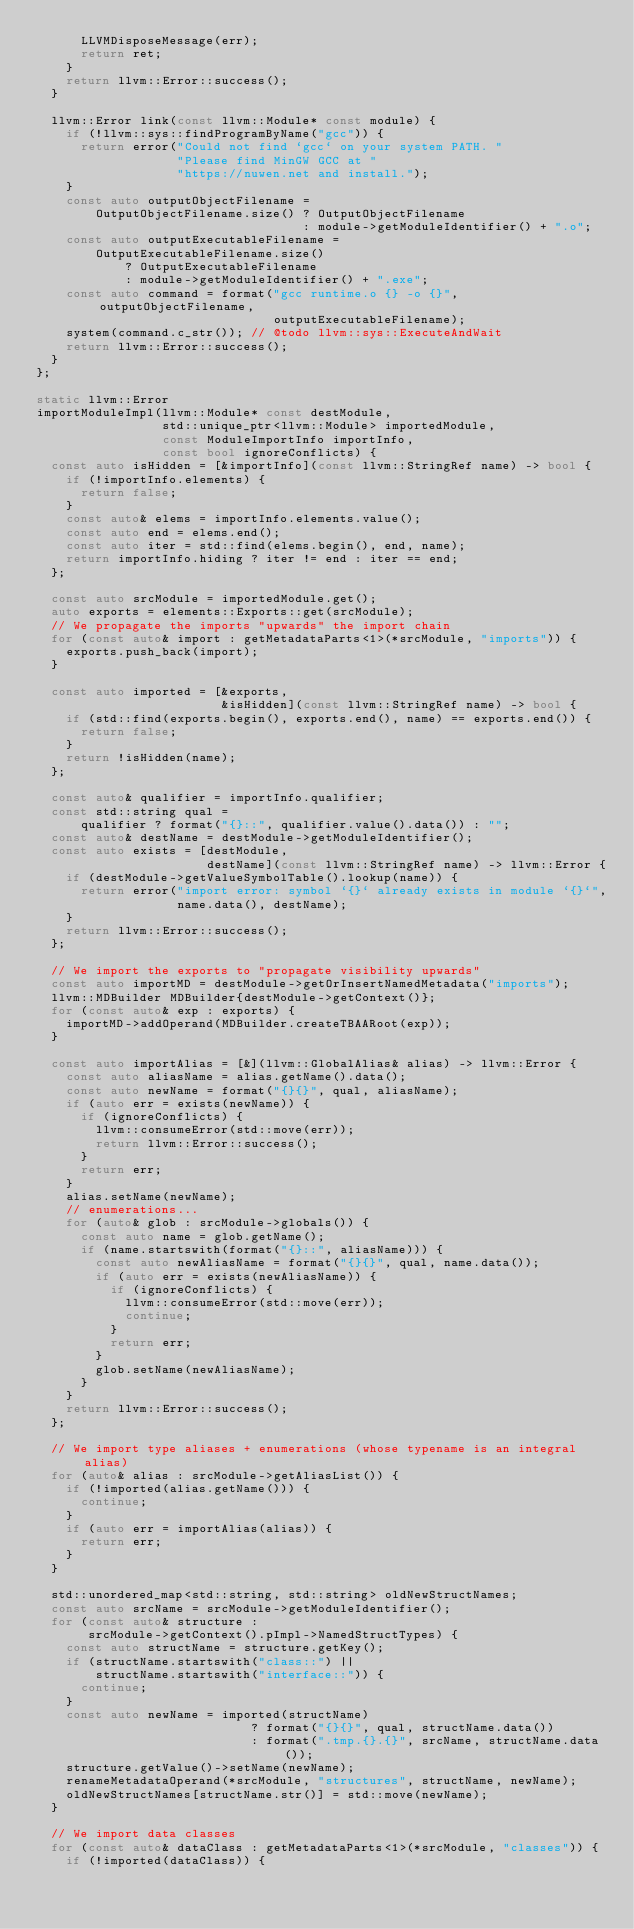<code> <loc_0><loc_0><loc_500><loc_500><_C++_>      LLVMDisposeMessage(err);
      return ret;
    }
    return llvm::Error::success();
  }

  llvm::Error link(const llvm::Module* const module) {
    if (!llvm::sys::findProgramByName("gcc")) {
      return error("Could not find `gcc` on your system PATH. "
                   "Please find MinGW GCC at "
                   "https://nuwen.net and install.");
    }
    const auto outputObjectFilename =
        OutputObjectFilename.size() ? OutputObjectFilename
                                    : module->getModuleIdentifier() + ".o";
    const auto outputExecutableFilename =
        OutputExecutableFilename.size()
            ? OutputExecutableFilename
            : module->getModuleIdentifier() + ".exe";
    const auto command = format("gcc runtime.o {} -o {}", outputObjectFilename,
                                outputExecutableFilename);
    system(command.c_str()); // @todo llvm::sys::ExecuteAndWait
    return llvm::Error::success();
  }
};

static llvm::Error
importModuleImpl(llvm::Module* const destModule,
                 std::unique_ptr<llvm::Module> importedModule,
                 const ModuleImportInfo importInfo,
                 const bool ignoreConflicts) {
  const auto isHidden = [&importInfo](const llvm::StringRef name) -> bool {
    if (!importInfo.elements) {
      return false;
    }
    const auto& elems = importInfo.elements.value();
    const auto end = elems.end();
    const auto iter = std::find(elems.begin(), end, name);
    return importInfo.hiding ? iter != end : iter == end;
  };

  const auto srcModule = importedModule.get();
  auto exports = elements::Exports::get(srcModule);
  // We propagate the imports "upwards" the import chain
  for (const auto& import : getMetadataParts<1>(*srcModule, "imports")) {
    exports.push_back(import);
  }

  const auto imported = [&exports,
                         &isHidden](const llvm::StringRef name) -> bool {
    if (std::find(exports.begin(), exports.end(), name) == exports.end()) {
      return false;
    }
    return !isHidden(name);
  };

  const auto& qualifier = importInfo.qualifier;
  const std::string qual =
      qualifier ? format("{}::", qualifier.value().data()) : "";
  const auto& destName = destModule->getModuleIdentifier();
  const auto exists = [destModule,
                       destName](const llvm::StringRef name) -> llvm::Error {
    if (destModule->getValueSymbolTable().lookup(name)) {
      return error("import error: symbol `{}` already exists in module `{}`",
                   name.data(), destName);
    }
    return llvm::Error::success();
  };

  // We import the exports to "propagate visibility upwards"
  const auto importMD = destModule->getOrInsertNamedMetadata("imports");
  llvm::MDBuilder MDBuilder{destModule->getContext()};
  for (const auto& exp : exports) {
    importMD->addOperand(MDBuilder.createTBAARoot(exp));
  }

  const auto importAlias = [&](llvm::GlobalAlias& alias) -> llvm::Error {
    const auto aliasName = alias.getName().data();
    const auto newName = format("{}{}", qual, aliasName);
    if (auto err = exists(newName)) {
      if (ignoreConflicts) {
        llvm::consumeError(std::move(err));
        return llvm::Error::success();
      }
      return err;
    }
    alias.setName(newName);
    // enumerations...
    for (auto& glob : srcModule->globals()) {
      const auto name = glob.getName();
      if (name.startswith(format("{}::", aliasName))) {
        const auto newAliasName = format("{}{}", qual, name.data());
        if (auto err = exists(newAliasName)) {
          if (ignoreConflicts) {
            llvm::consumeError(std::move(err));
            continue;
          }
          return err;
        }
        glob.setName(newAliasName);
      }
    }
    return llvm::Error::success();
  };

  // We import type aliases + enumerations (whose typename is an integral alias)
  for (auto& alias : srcModule->getAliasList()) {
    if (!imported(alias.getName())) {
      continue;
    }
    if (auto err = importAlias(alias)) {
      return err;
    }
  }

  std::unordered_map<std::string, std::string> oldNewStructNames;
  const auto srcName = srcModule->getModuleIdentifier();
  for (const auto& structure :
       srcModule->getContext().pImpl->NamedStructTypes) {
    const auto structName = structure.getKey();
    if (structName.startswith("class::") ||
        structName.startswith("interface::")) {
      continue;
    }
    const auto newName = imported(structName)
                             ? format("{}{}", qual, structName.data())
                             : format(".tmp.{}.{}", srcName, structName.data());
    structure.getValue()->setName(newName);
    renameMetadataOperand(*srcModule, "structures", structName, newName);
    oldNewStructNames[structName.str()] = std::move(newName);
  }

  // We import data classes
  for (const auto& dataClass : getMetadataParts<1>(*srcModule, "classes")) {
    if (!imported(dataClass)) {</code> 